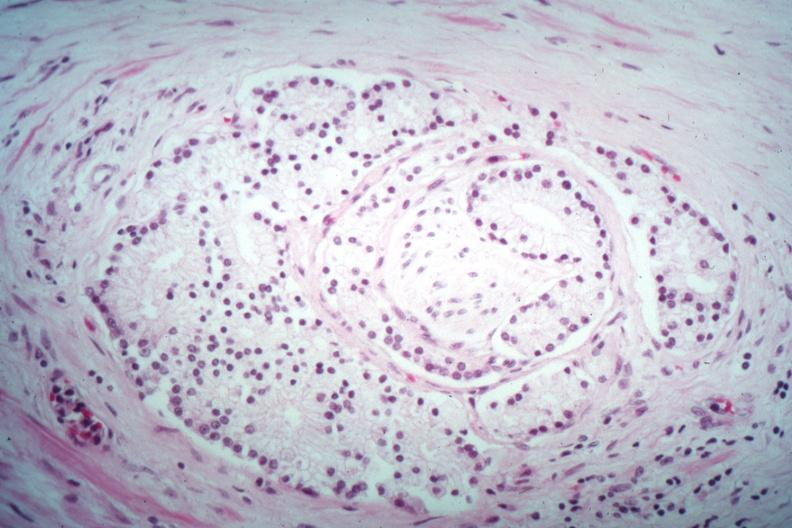does this image show nice perineural invasion by well differentiated adenocarcinoma?
Answer the question using a single word or phrase. Yes 